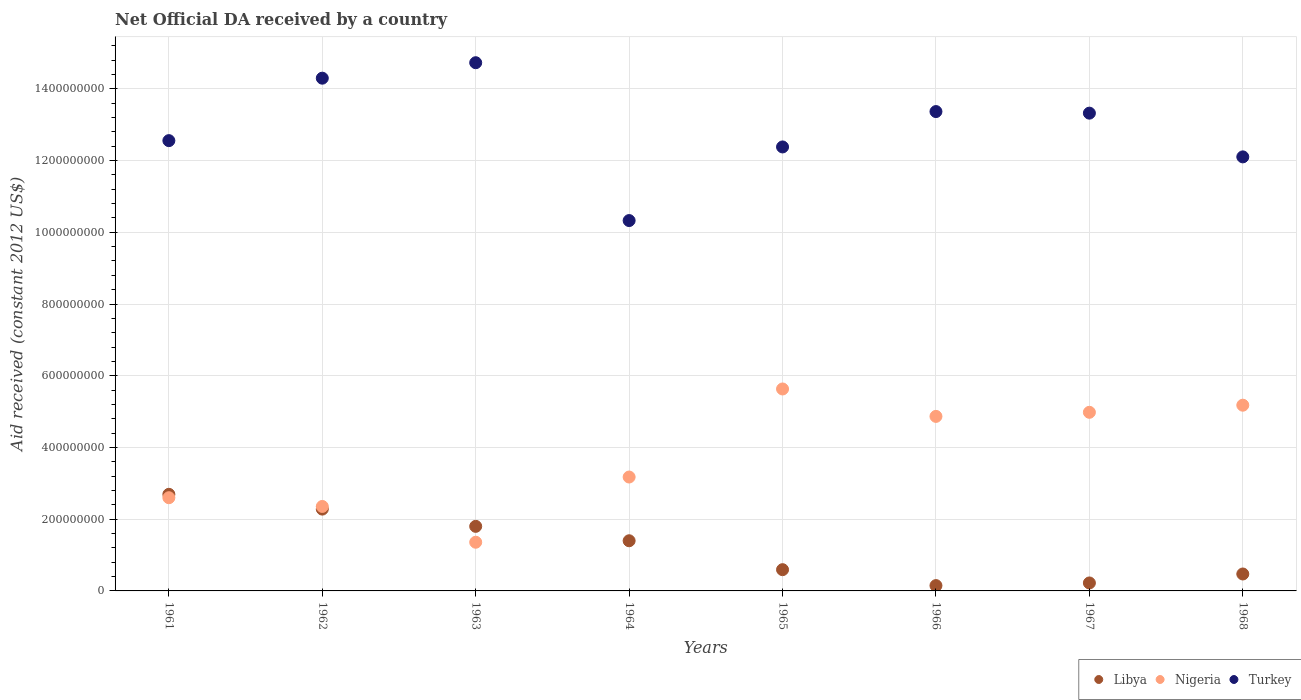What is the net official development assistance aid received in Nigeria in 1962?
Your answer should be compact. 2.36e+08. Across all years, what is the maximum net official development assistance aid received in Nigeria?
Your response must be concise. 5.63e+08. Across all years, what is the minimum net official development assistance aid received in Nigeria?
Your response must be concise. 1.36e+08. In which year was the net official development assistance aid received in Nigeria maximum?
Ensure brevity in your answer.  1965. What is the total net official development assistance aid received in Turkey in the graph?
Your response must be concise. 1.03e+1. What is the difference between the net official development assistance aid received in Libya in 1965 and that in 1968?
Your answer should be very brief. 1.20e+07. What is the difference between the net official development assistance aid received in Libya in 1968 and the net official development assistance aid received in Turkey in 1963?
Ensure brevity in your answer.  -1.43e+09. What is the average net official development assistance aid received in Libya per year?
Your answer should be very brief. 1.20e+08. In the year 1965, what is the difference between the net official development assistance aid received in Turkey and net official development assistance aid received in Nigeria?
Your answer should be very brief. 6.75e+08. In how many years, is the net official development assistance aid received in Nigeria greater than 200000000 US$?
Give a very brief answer. 7. What is the ratio of the net official development assistance aid received in Libya in 1962 to that in 1963?
Make the answer very short. 1.27. What is the difference between the highest and the second highest net official development assistance aid received in Libya?
Offer a terse response. 4.12e+07. What is the difference between the highest and the lowest net official development assistance aid received in Turkey?
Provide a short and direct response. 4.40e+08. In how many years, is the net official development assistance aid received in Libya greater than the average net official development assistance aid received in Libya taken over all years?
Offer a very short reply. 4. Does the net official development assistance aid received in Nigeria monotonically increase over the years?
Provide a succinct answer. No. Is the net official development assistance aid received in Turkey strictly greater than the net official development assistance aid received in Nigeria over the years?
Make the answer very short. Yes. How many dotlines are there?
Provide a short and direct response. 3. Are the values on the major ticks of Y-axis written in scientific E-notation?
Provide a succinct answer. No. Does the graph contain any zero values?
Make the answer very short. No. Where does the legend appear in the graph?
Your answer should be very brief. Bottom right. How are the legend labels stacked?
Give a very brief answer. Horizontal. What is the title of the graph?
Keep it short and to the point. Net Official DA received by a country. What is the label or title of the X-axis?
Your answer should be very brief. Years. What is the label or title of the Y-axis?
Your answer should be very brief. Aid received (constant 2012 US$). What is the Aid received (constant 2012 US$) of Libya in 1961?
Your response must be concise. 2.69e+08. What is the Aid received (constant 2012 US$) of Nigeria in 1961?
Provide a succinct answer. 2.60e+08. What is the Aid received (constant 2012 US$) of Turkey in 1961?
Give a very brief answer. 1.26e+09. What is the Aid received (constant 2012 US$) in Libya in 1962?
Provide a succinct answer. 2.28e+08. What is the Aid received (constant 2012 US$) in Nigeria in 1962?
Provide a short and direct response. 2.36e+08. What is the Aid received (constant 2012 US$) of Turkey in 1962?
Make the answer very short. 1.43e+09. What is the Aid received (constant 2012 US$) in Libya in 1963?
Make the answer very short. 1.80e+08. What is the Aid received (constant 2012 US$) in Nigeria in 1963?
Offer a very short reply. 1.36e+08. What is the Aid received (constant 2012 US$) of Turkey in 1963?
Your response must be concise. 1.47e+09. What is the Aid received (constant 2012 US$) of Libya in 1964?
Keep it short and to the point. 1.40e+08. What is the Aid received (constant 2012 US$) of Nigeria in 1964?
Offer a terse response. 3.18e+08. What is the Aid received (constant 2012 US$) of Turkey in 1964?
Provide a succinct answer. 1.03e+09. What is the Aid received (constant 2012 US$) of Libya in 1965?
Provide a short and direct response. 5.92e+07. What is the Aid received (constant 2012 US$) in Nigeria in 1965?
Your answer should be very brief. 5.63e+08. What is the Aid received (constant 2012 US$) in Turkey in 1965?
Your answer should be compact. 1.24e+09. What is the Aid received (constant 2012 US$) of Libya in 1966?
Provide a succinct answer. 1.49e+07. What is the Aid received (constant 2012 US$) of Nigeria in 1966?
Your answer should be compact. 4.87e+08. What is the Aid received (constant 2012 US$) of Turkey in 1966?
Offer a very short reply. 1.34e+09. What is the Aid received (constant 2012 US$) in Libya in 1967?
Give a very brief answer. 2.22e+07. What is the Aid received (constant 2012 US$) in Nigeria in 1967?
Your answer should be compact. 4.98e+08. What is the Aid received (constant 2012 US$) of Turkey in 1967?
Provide a succinct answer. 1.33e+09. What is the Aid received (constant 2012 US$) of Libya in 1968?
Provide a short and direct response. 4.72e+07. What is the Aid received (constant 2012 US$) of Nigeria in 1968?
Your response must be concise. 5.18e+08. What is the Aid received (constant 2012 US$) in Turkey in 1968?
Ensure brevity in your answer.  1.21e+09. Across all years, what is the maximum Aid received (constant 2012 US$) of Libya?
Offer a very short reply. 2.69e+08. Across all years, what is the maximum Aid received (constant 2012 US$) of Nigeria?
Offer a very short reply. 5.63e+08. Across all years, what is the maximum Aid received (constant 2012 US$) of Turkey?
Your response must be concise. 1.47e+09. Across all years, what is the minimum Aid received (constant 2012 US$) in Libya?
Make the answer very short. 1.49e+07. Across all years, what is the minimum Aid received (constant 2012 US$) in Nigeria?
Your answer should be very brief. 1.36e+08. Across all years, what is the minimum Aid received (constant 2012 US$) of Turkey?
Your answer should be compact. 1.03e+09. What is the total Aid received (constant 2012 US$) of Libya in the graph?
Give a very brief answer. 9.61e+08. What is the total Aid received (constant 2012 US$) in Nigeria in the graph?
Provide a short and direct response. 3.01e+09. What is the total Aid received (constant 2012 US$) of Turkey in the graph?
Your answer should be very brief. 1.03e+1. What is the difference between the Aid received (constant 2012 US$) of Libya in 1961 and that in 1962?
Your answer should be compact. 4.12e+07. What is the difference between the Aid received (constant 2012 US$) of Nigeria in 1961 and that in 1962?
Make the answer very short. 2.44e+07. What is the difference between the Aid received (constant 2012 US$) of Turkey in 1961 and that in 1962?
Provide a short and direct response. -1.74e+08. What is the difference between the Aid received (constant 2012 US$) in Libya in 1961 and that in 1963?
Give a very brief answer. 8.93e+07. What is the difference between the Aid received (constant 2012 US$) of Nigeria in 1961 and that in 1963?
Keep it short and to the point. 1.24e+08. What is the difference between the Aid received (constant 2012 US$) of Turkey in 1961 and that in 1963?
Your answer should be compact. -2.17e+08. What is the difference between the Aid received (constant 2012 US$) in Libya in 1961 and that in 1964?
Your answer should be very brief. 1.29e+08. What is the difference between the Aid received (constant 2012 US$) in Nigeria in 1961 and that in 1964?
Provide a succinct answer. -5.77e+07. What is the difference between the Aid received (constant 2012 US$) of Turkey in 1961 and that in 1964?
Keep it short and to the point. 2.23e+08. What is the difference between the Aid received (constant 2012 US$) in Libya in 1961 and that in 1965?
Your response must be concise. 2.10e+08. What is the difference between the Aid received (constant 2012 US$) of Nigeria in 1961 and that in 1965?
Keep it short and to the point. -3.03e+08. What is the difference between the Aid received (constant 2012 US$) of Turkey in 1961 and that in 1965?
Your response must be concise. 1.76e+07. What is the difference between the Aid received (constant 2012 US$) of Libya in 1961 and that in 1966?
Ensure brevity in your answer.  2.54e+08. What is the difference between the Aid received (constant 2012 US$) in Nigeria in 1961 and that in 1966?
Give a very brief answer. -2.27e+08. What is the difference between the Aid received (constant 2012 US$) in Turkey in 1961 and that in 1966?
Offer a terse response. -8.10e+07. What is the difference between the Aid received (constant 2012 US$) in Libya in 1961 and that in 1967?
Offer a very short reply. 2.47e+08. What is the difference between the Aid received (constant 2012 US$) of Nigeria in 1961 and that in 1967?
Offer a very short reply. -2.38e+08. What is the difference between the Aid received (constant 2012 US$) in Turkey in 1961 and that in 1967?
Offer a very short reply. -7.66e+07. What is the difference between the Aid received (constant 2012 US$) in Libya in 1961 and that in 1968?
Keep it short and to the point. 2.22e+08. What is the difference between the Aid received (constant 2012 US$) of Nigeria in 1961 and that in 1968?
Give a very brief answer. -2.58e+08. What is the difference between the Aid received (constant 2012 US$) in Turkey in 1961 and that in 1968?
Ensure brevity in your answer.  4.53e+07. What is the difference between the Aid received (constant 2012 US$) in Libya in 1962 and that in 1963?
Your answer should be compact. 4.81e+07. What is the difference between the Aid received (constant 2012 US$) of Nigeria in 1962 and that in 1963?
Give a very brief answer. 9.98e+07. What is the difference between the Aid received (constant 2012 US$) in Turkey in 1962 and that in 1963?
Your answer should be compact. -4.31e+07. What is the difference between the Aid received (constant 2012 US$) in Libya in 1962 and that in 1964?
Keep it short and to the point. 8.83e+07. What is the difference between the Aid received (constant 2012 US$) in Nigeria in 1962 and that in 1964?
Give a very brief answer. -8.20e+07. What is the difference between the Aid received (constant 2012 US$) of Turkey in 1962 and that in 1964?
Your answer should be very brief. 3.97e+08. What is the difference between the Aid received (constant 2012 US$) in Libya in 1962 and that in 1965?
Give a very brief answer. 1.69e+08. What is the difference between the Aid received (constant 2012 US$) of Nigeria in 1962 and that in 1965?
Offer a very short reply. -3.28e+08. What is the difference between the Aid received (constant 2012 US$) in Turkey in 1962 and that in 1965?
Offer a very short reply. 1.92e+08. What is the difference between the Aid received (constant 2012 US$) in Libya in 1962 and that in 1966?
Your answer should be compact. 2.13e+08. What is the difference between the Aid received (constant 2012 US$) in Nigeria in 1962 and that in 1966?
Your response must be concise. -2.51e+08. What is the difference between the Aid received (constant 2012 US$) in Turkey in 1962 and that in 1966?
Keep it short and to the point. 9.31e+07. What is the difference between the Aid received (constant 2012 US$) in Libya in 1962 and that in 1967?
Offer a very short reply. 2.06e+08. What is the difference between the Aid received (constant 2012 US$) in Nigeria in 1962 and that in 1967?
Offer a very short reply. -2.63e+08. What is the difference between the Aid received (constant 2012 US$) in Turkey in 1962 and that in 1967?
Your answer should be very brief. 9.75e+07. What is the difference between the Aid received (constant 2012 US$) of Libya in 1962 and that in 1968?
Your answer should be very brief. 1.81e+08. What is the difference between the Aid received (constant 2012 US$) of Nigeria in 1962 and that in 1968?
Provide a short and direct response. -2.82e+08. What is the difference between the Aid received (constant 2012 US$) of Turkey in 1962 and that in 1968?
Ensure brevity in your answer.  2.19e+08. What is the difference between the Aid received (constant 2012 US$) of Libya in 1963 and that in 1964?
Offer a very short reply. 4.02e+07. What is the difference between the Aid received (constant 2012 US$) in Nigeria in 1963 and that in 1964?
Provide a short and direct response. -1.82e+08. What is the difference between the Aid received (constant 2012 US$) of Turkey in 1963 and that in 1964?
Ensure brevity in your answer.  4.40e+08. What is the difference between the Aid received (constant 2012 US$) in Libya in 1963 and that in 1965?
Ensure brevity in your answer.  1.21e+08. What is the difference between the Aid received (constant 2012 US$) in Nigeria in 1963 and that in 1965?
Provide a succinct answer. -4.27e+08. What is the difference between the Aid received (constant 2012 US$) of Turkey in 1963 and that in 1965?
Your response must be concise. 2.35e+08. What is the difference between the Aid received (constant 2012 US$) in Libya in 1963 and that in 1966?
Provide a short and direct response. 1.65e+08. What is the difference between the Aid received (constant 2012 US$) in Nigeria in 1963 and that in 1966?
Keep it short and to the point. -3.51e+08. What is the difference between the Aid received (constant 2012 US$) of Turkey in 1963 and that in 1966?
Offer a very short reply. 1.36e+08. What is the difference between the Aid received (constant 2012 US$) in Libya in 1963 and that in 1967?
Keep it short and to the point. 1.58e+08. What is the difference between the Aid received (constant 2012 US$) in Nigeria in 1963 and that in 1967?
Make the answer very short. -3.62e+08. What is the difference between the Aid received (constant 2012 US$) of Turkey in 1963 and that in 1967?
Offer a very short reply. 1.41e+08. What is the difference between the Aid received (constant 2012 US$) of Libya in 1963 and that in 1968?
Offer a terse response. 1.33e+08. What is the difference between the Aid received (constant 2012 US$) of Nigeria in 1963 and that in 1968?
Offer a very short reply. -3.82e+08. What is the difference between the Aid received (constant 2012 US$) of Turkey in 1963 and that in 1968?
Give a very brief answer. 2.63e+08. What is the difference between the Aid received (constant 2012 US$) of Libya in 1964 and that in 1965?
Offer a very short reply. 8.06e+07. What is the difference between the Aid received (constant 2012 US$) of Nigeria in 1964 and that in 1965?
Provide a succinct answer. -2.46e+08. What is the difference between the Aid received (constant 2012 US$) in Turkey in 1964 and that in 1965?
Your answer should be compact. -2.05e+08. What is the difference between the Aid received (constant 2012 US$) of Libya in 1964 and that in 1966?
Your response must be concise. 1.25e+08. What is the difference between the Aid received (constant 2012 US$) of Nigeria in 1964 and that in 1966?
Provide a succinct answer. -1.69e+08. What is the difference between the Aid received (constant 2012 US$) of Turkey in 1964 and that in 1966?
Your answer should be compact. -3.04e+08. What is the difference between the Aid received (constant 2012 US$) in Libya in 1964 and that in 1967?
Your answer should be very brief. 1.18e+08. What is the difference between the Aid received (constant 2012 US$) of Nigeria in 1964 and that in 1967?
Keep it short and to the point. -1.80e+08. What is the difference between the Aid received (constant 2012 US$) of Turkey in 1964 and that in 1967?
Your answer should be very brief. -3.00e+08. What is the difference between the Aid received (constant 2012 US$) of Libya in 1964 and that in 1968?
Offer a terse response. 9.26e+07. What is the difference between the Aid received (constant 2012 US$) in Nigeria in 1964 and that in 1968?
Offer a terse response. -2.00e+08. What is the difference between the Aid received (constant 2012 US$) of Turkey in 1964 and that in 1968?
Your answer should be compact. -1.78e+08. What is the difference between the Aid received (constant 2012 US$) of Libya in 1965 and that in 1966?
Your response must be concise. 4.44e+07. What is the difference between the Aid received (constant 2012 US$) in Nigeria in 1965 and that in 1966?
Offer a very short reply. 7.64e+07. What is the difference between the Aid received (constant 2012 US$) in Turkey in 1965 and that in 1966?
Offer a very short reply. -9.86e+07. What is the difference between the Aid received (constant 2012 US$) in Libya in 1965 and that in 1967?
Your response must be concise. 3.70e+07. What is the difference between the Aid received (constant 2012 US$) of Nigeria in 1965 and that in 1967?
Give a very brief answer. 6.51e+07. What is the difference between the Aid received (constant 2012 US$) in Turkey in 1965 and that in 1967?
Provide a succinct answer. -9.42e+07. What is the difference between the Aid received (constant 2012 US$) in Libya in 1965 and that in 1968?
Provide a short and direct response. 1.20e+07. What is the difference between the Aid received (constant 2012 US$) of Nigeria in 1965 and that in 1968?
Your answer should be very brief. 4.52e+07. What is the difference between the Aid received (constant 2012 US$) of Turkey in 1965 and that in 1968?
Keep it short and to the point. 2.77e+07. What is the difference between the Aid received (constant 2012 US$) in Libya in 1966 and that in 1967?
Keep it short and to the point. -7.36e+06. What is the difference between the Aid received (constant 2012 US$) of Nigeria in 1966 and that in 1967?
Your answer should be very brief. -1.14e+07. What is the difference between the Aid received (constant 2012 US$) in Turkey in 1966 and that in 1967?
Give a very brief answer. 4.41e+06. What is the difference between the Aid received (constant 2012 US$) of Libya in 1966 and that in 1968?
Ensure brevity in your answer.  -3.24e+07. What is the difference between the Aid received (constant 2012 US$) in Nigeria in 1966 and that in 1968?
Provide a succinct answer. -3.12e+07. What is the difference between the Aid received (constant 2012 US$) of Turkey in 1966 and that in 1968?
Your answer should be very brief. 1.26e+08. What is the difference between the Aid received (constant 2012 US$) in Libya in 1967 and that in 1968?
Your response must be concise. -2.50e+07. What is the difference between the Aid received (constant 2012 US$) in Nigeria in 1967 and that in 1968?
Give a very brief answer. -1.98e+07. What is the difference between the Aid received (constant 2012 US$) of Turkey in 1967 and that in 1968?
Offer a very short reply. 1.22e+08. What is the difference between the Aid received (constant 2012 US$) of Libya in 1961 and the Aid received (constant 2012 US$) of Nigeria in 1962?
Provide a succinct answer. 3.38e+07. What is the difference between the Aid received (constant 2012 US$) in Libya in 1961 and the Aid received (constant 2012 US$) in Turkey in 1962?
Ensure brevity in your answer.  -1.16e+09. What is the difference between the Aid received (constant 2012 US$) in Nigeria in 1961 and the Aid received (constant 2012 US$) in Turkey in 1962?
Offer a very short reply. -1.17e+09. What is the difference between the Aid received (constant 2012 US$) of Libya in 1961 and the Aid received (constant 2012 US$) of Nigeria in 1963?
Provide a short and direct response. 1.34e+08. What is the difference between the Aid received (constant 2012 US$) of Libya in 1961 and the Aid received (constant 2012 US$) of Turkey in 1963?
Offer a terse response. -1.20e+09. What is the difference between the Aid received (constant 2012 US$) in Nigeria in 1961 and the Aid received (constant 2012 US$) in Turkey in 1963?
Your answer should be very brief. -1.21e+09. What is the difference between the Aid received (constant 2012 US$) of Libya in 1961 and the Aid received (constant 2012 US$) of Nigeria in 1964?
Provide a short and direct response. -4.82e+07. What is the difference between the Aid received (constant 2012 US$) in Libya in 1961 and the Aid received (constant 2012 US$) in Turkey in 1964?
Your answer should be very brief. -7.63e+08. What is the difference between the Aid received (constant 2012 US$) of Nigeria in 1961 and the Aid received (constant 2012 US$) of Turkey in 1964?
Offer a terse response. -7.73e+08. What is the difference between the Aid received (constant 2012 US$) of Libya in 1961 and the Aid received (constant 2012 US$) of Nigeria in 1965?
Your answer should be compact. -2.94e+08. What is the difference between the Aid received (constant 2012 US$) in Libya in 1961 and the Aid received (constant 2012 US$) in Turkey in 1965?
Keep it short and to the point. -9.69e+08. What is the difference between the Aid received (constant 2012 US$) in Nigeria in 1961 and the Aid received (constant 2012 US$) in Turkey in 1965?
Provide a short and direct response. -9.78e+08. What is the difference between the Aid received (constant 2012 US$) of Libya in 1961 and the Aid received (constant 2012 US$) of Nigeria in 1966?
Ensure brevity in your answer.  -2.17e+08. What is the difference between the Aid received (constant 2012 US$) of Libya in 1961 and the Aid received (constant 2012 US$) of Turkey in 1966?
Provide a short and direct response. -1.07e+09. What is the difference between the Aid received (constant 2012 US$) of Nigeria in 1961 and the Aid received (constant 2012 US$) of Turkey in 1966?
Offer a terse response. -1.08e+09. What is the difference between the Aid received (constant 2012 US$) in Libya in 1961 and the Aid received (constant 2012 US$) in Nigeria in 1967?
Keep it short and to the point. -2.29e+08. What is the difference between the Aid received (constant 2012 US$) in Libya in 1961 and the Aid received (constant 2012 US$) in Turkey in 1967?
Ensure brevity in your answer.  -1.06e+09. What is the difference between the Aid received (constant 2012 US$) of Nigeria in 1961 and the Aid received (constant 2012 US$) of Turkey in 1967?
Provide a short and direct response. -1.07e+09. What is the difference between the Aid received (constant 2012 US$) of Libya in 1961 and the Aid received (constant 2012 US$) of Nigeria in 1968?
Ensure brevity in your answer.  -2.49e+08. What is the difference between the Aid received (constant 2012 US$) of Libya in 1961 and the Aid received (constant 2012 US$) of Turkey in 1968?
Ensure brevity in your answer.  -9.41e+08. What is the difference between the Aid received (constant 2012 US$) in Nigeria in 1961 and the Aid received (constant 2012 US$) in Turkey in 1968?
Keep it short and to the point. -9.50e+08. What is the difference between the Aid received (constant 2012 US$) of Libya in 1962 and the Aid received (constant 2012 US$) of Nigeria in 1963?
Ensure brevity in your answer.  9.24e+07. What is the difference between the Aid received (constant 2012 US$) of Libya in 1962 and the Aid received (constant 2012 US$) of Turkey in 1963?
Provide a short and direct response. -1.24e+09. What is the difference between the Aid received (constant 2012 US$) in Nigeria in 1962 and the Aid received (constant 2012 US$) in Turkey in 1963?
Your answer should be compact. -1.24e+09. What is the difference between the Aid received (constant 2012 US$) of Libya in 1962 and the Aid received (constant 2012 US$) of Nigeria in 1964?
Provide a short and direct response. -8.94e+07. What is the difference between the Aid received (constant 2012 US$) of Libya in 1962 and the Aid received (constant 2012 US$) of Turkey in 1964?
Provide a succinct answer. -8.05e+08. What is the difference between the Aid received (constant 2012 US$) of Nigeria in 1962 and the Aid received (constant 2012 US$) of Turkey in 1964?
Provide a succinct answer. -7.97e+08. What is the difference between the Aid received (constant 2012 US$) in Libya in 1962 and the Aid received (constant 2012 US$) in Nigeria in 1965?
Ensure brevity in your answer.  -3.35e+08. What is the difference between the Aid received (constant 2012 US$) of Libya in 1962 and the Aid received (constant 2012 US$) of Turkey in 1965?
Your answer should be very brief. -1.01e+09. What is the difference between the Aid received (constant 2012 US$) of Nigeria in 1962 and the Aid received (constant 2012 US$) of Turkey in 1965?
Your response must be concise. -1.00e+09. What is the difference between the Aid received (constant 2012 US$) of Libya in 1962 and the Aid received (constant 2012 US$) of Nigeria in 1966?
Your response must be concise. -2.59e+08. What is the difference between the Aid received (constant 2012 US$) of Libya in 1962 and the Aid received (constant 2012 US$) of Turkey in 1966?
Offer a very short reply. -1.11e+09. What is the difference between the Aid received (constant 2012 US$) of Nigeria in 1962 and the Aid received (constant 2012 US$) of Turkey in 1966?
Keep it short and to the point. -1.10e+09. What is the difference between the Aid received (constant 2012 US$) in Libya in 1962 and the Aid received (constant 2012 US$) in Nigeria in 1967?
Offer a very short reply. -2.70e+08. What is the difference between the Aid received (constant 2012 US$) in Libya in 1962 and the Aid received (constant 2012 US$) in Turkey in 1967?
Provide a succinct answer. -1.10e+09. What is the difference between the Aid received (constant 2012 US$) in Nigeria in 1962 and the Aid received (constant 2012 US$) in Turkey in 1967?
Provide a short and direct response. -1.10e+09. What is the difference between the Aid received (constant 2012 US$) of Libya in 1962 and the Aid received (constant 2012 US$) of Nigeria in 1968?
Keep it short and to the point. -2.90e+08. What is the difference between the Aid received (constant 2012 US$) of Libya in 1962 and the Aid received (constant 2012 US$) of Turkey in 1968?
Your answer should be compact. -9.82e+08. What is the difference between the Aid received (constant 2012 US$) of Nigeria in 1962 and the Aid received (constant 2012 US$) of Turkey in 1968?
Provide a short and direct response. -9.75e+08. What is the difference between the Aid received (constant 2012 US$) in Libya in 1963 and the Aid received (constant 2012 US$) in Nigeria in 1964?
Your response must be concise. -1.38e+08. What is the difference between the Aid received (constant 2012 US$) of Libya in 1963 and the Aid received (constant 2012 US$) of Turkey in 1964?
Provide a short and direct response. -8.53e+08. What is the difference between the Aid received (constant 2012 US$) of Nigeria in 1963 and the Aid received (constant 2012 US$) of Turkey in 1964?
Provide a short and direct response. -8.97e+08. What is the difference between the Aid received (constant 2012 US$) of Libya in 1963 and the Aid received (constant 2012 US$) of Nigeria in 1965?
Your answer should be very brief. -3.83e+08. What is the difference between the Aid received (constant 2012 US$) in Libya in 1963 and the Aid received (constant 2012 US$) in Turkey in 1965?
Keep it short and to the point. -1.06e+09. What is the difference between the Aid received (constant 2012 US$) in Nigeria in 1963 and the Aid received (constant 2012 US$) in Turkey in 1965?
Keep it short and to the point. -1.10e+09. What is the difference between the Aid received (constant 2012 US$) of Libya in 1963 and the Aid received (constant 2012 US$) of Nigeria in 1966?
Your answer should be very brief. -3.07e+08. What is the difference between the Aid received (constant 2012 US$) in Libya in 1963 and the Aid received (constant 2012 US$) in Turkey in 1966?
Your response must be concise. -1.16e+09. What is the difference between the Aid received (constant 2012 US$) of Nigeria in 1963 and the Aid received (constant 2012 US$) of Turkey in 1966?
Your answer should be compact. -1.20e+09. What is the difference between the Aid received (constant 2012 US$) of Libya in 1963 and the Aid received (constant 2012 US$) of Nigeria in 1967?
Your answer should be very brief. -3.18e+08. What is the difference between the Aid received (constant 2012 US$) in Libya in 1963 and the Aid received (constant 2012 US$) in Turkey in 1967?
Provide a short and direct response. -1.15e+09. What is the difference between the Aid received (constant 2012 US$) of Nigeria in 1963 and the Aid received (constant 2012 US$) of Turkey in 1967?
Offer a terse response. -1.20e+09. What is the difference between the Aid received (constant 2012 US$) of Libya in 1963 and the Aid received (constant 2012 US$) of Nigeria in 1968?
Make the answer very short. -3.38e+08. What is the difference between the Aid received (constant 2012 US$) of Libya in 1963 and the Aid received (constant 2012 US$) of Turkey in 1968?
Provide a short and direct response. -1.03e+09. What is the difference between the Aid received (constant 2012 US$) in Nigeria in 1963 and the Aid received (constant 2012 US$) in Turkey in 1968?
Your answer should be compact. -1.07e+09. What is the difference between the Aid received (constant 2012 US$) in Libya in 1964 and the Aid received (constant 2012 US$) in Nigeria in 1965?
Offer a terse response. -4.23e+08. What is the difference between the Aid received (constant 2012 US$) of Libya in 1964 and the Aid received (constant 2012 US$) of Turkey in 1965?
Your answer should be compact. -1.10e+09. What is the difference between the Aid received (constant 2012 US$) in Nigeria in 1964 and the Aid received (constant 2012 US$) in Turkey in 1965?
Provide a short and direct response. -9.20e+08. What is the difference between the Aid received (constant 2012 US$) of Libya in 1964 and the Aid received (constant 2012 US$) of Nigeria in 1966?
Offer a terse response. -3.47e+08. What is the difference between the Aid received (constant 2012 US$) of Libya in 1964 and the Aid received (constant 2012 US$) of Turkey in 1966?
Provide a succinct answer. -1.20e+09. What is the difference between the Aid received (constant 2012 US$) in Nigeria in 1964 and the Aid received (constant 2012 US$) in Turkey in 1966?
Offer a very short reply. -1.02e+09. What is the difference between the Aid received (constant 2012 US$) in Libya in 1964 and the Aid received (constant 2012 US$) in Nigeria in 1967?
Your answer should be very brief. -3.58e+08. What is the difference between the Aid received (constant 2012 US$) in Libya in 1964 and the Aid received (constant 2012 US$) in Turkey in 1967?
Your response must be concise. -1.19e+09. What is the difference between the Aid received (constant 2012 US$) of Nigeria in 1964 and the Aid received (constant 2012 US$) of Turkey in 1967?
Keep it short and to the point. -1.01e+09. What is the difference between the Aid received (constant 2012 US$) in Libya in 1964 and the Aid received (constant 2012 US$) in Nigeria in 1968?
Your answer should be compact. -3.78e+08. What is the difference between the Aid received (constant 2012 US$) of Libya in 1964 and the Aid received (constant 2012 US$) of Turkey in 1968?
Offer a very short reply. -1.07e+09. What is the difference between the Aid received (constant 2012 US$) of Nigeria in 1964 and the Aid received (constant 2012 US$) of Turkey in 1968?
Your answer should be compact. -8.93e+08. What is the difference between the Aid received (constant 2012 US$) in Libya in 1965 and the Aid received (constant 2012 US$) in Nigeria in 1966?
Your answer should be compact. -4.27e+08. What is the difference between the Aid received (constant 2012 US$) of Libya in 1965 and the Aid received (constant 2012 US$) of Turkey in 1966?
Keep it short and to the point. -1.28e+09. What is the difference between the Aid received (constant 2012 US$) in Nigeria in 1965 and the Aid received (constant 2012 US$) in Turkey in 1966?
Make the answer very short. -7.74e+08. What is the difference between the Aid received (constant 2012 US$) in Libya in 1965 and the Aid received (constant 2012 US$) in Nigeria in 1967?
Provide a succinct answer. -4.39e+08. What is the difference between the Aid received (constant 2012 US$) in Libya in 1965 and the Aid received (constant 2012 US$) in Turkey in 1967?
Ensure brevity in your answer.  -1.27e+09. What is the difference between the Aid received (constant 2012 US$) in Nigeria in 1965 and the Aid received (constant 2012 US$) in Turkey in 1967?
Offer a very short reply. -7.69e+08. What is the difference between the Aid received (constant 2012 US$) of Libya in 1965 and the Aid received (constant 2012 US$) of Nigeria in 1968?
Your answer should be very brief. -4.59e+08. What is the difference between the Aid received (constant 2012 US$) of Libya in 1965 and the Aid received (constant 2012 US$) of Turkey in 1968?
Provide a short and direct response. -1.15e+09. What is the difference between the Aid received (constant 2012 US$) in Nigeria in 1965 and the Aid received (constant 2012 US$) in Turkey in 1968?
Give a very brief answer. -6.47e+08. What is the difference between the Aid received (constant 2012 US$) of Libya in 1966 and the Aid received (constant 2012 US$) of Nigeria in 1967?
Offer a very short reply. -4.83e+08. What is the difference between the Aid received (constant 2012 US$) in Libya in 1966 and the Aid received (constant 2012 US$) in Turkey in 1967?
Keep it short and to the point. -1.32e+09. What is the difference between the Aid received (constant 2012 US$) of Nigeria in 1966 and the Aid received (constant 2012 US$) of Turkey in 1967?
Ensure brevity in your answer.  -8.46e+08. What is the difference between the Aid received (constant 2012 US$) of Libya in 1966 and the Aid received (constant 2012 US$) of Nigeria in 1968?
Offer a terse response. -5.03e+08. What is the difference between the Aid received (constant 2012 US$) in Libya in 1966 and the Aid received (constant 2012 US$) in Turkey in 1968?
Give a very brief answer. -1.20e+09. What is the difference between the Aid received (constant 2012 US$) of Nigeria in 1966 and the Aid received (constant 2012 US$) of Turkey in 1968?
Keep it short and to the point. -7.24e+08. What is the difference between the Aid received (constant 2012 US$) of Libya in 1967 and the Aid received (constant 2012 US$) of Nigeria in 1968?
Offer a terse response. -4.96e+08. What is the difference between the Aid received (constant 2012 US$) in Libya in 1967 and the Aid received (constant 2012 US$) in Turkey in 1968?
Give a very brief answer. -1.19e+09. What is the difference between the Aid received (constant 2012 US$) in Nigeria in 1967 and the Aid received (constant 2012 US$) in Turkey in 1968?
Make the answer very short. -7.12e+08. What is the average Aid received (constant 2012 US$) in Libya per year?
Provide a short and direct response. 1.20e+08. What is the average Aid received (constant 2012 US$) of Nigeria per year?
Provide a short and direct response. 3.77e+08. What is the average Aid received (constant 2012 US$) of Turkey per year?
Your answer should be very brief. 1.29e+09. In the year 1961, what is the difference between the Aid received (constant 2012 US$) of Libya and Aid received (constant 2012 US$) of Nigeria?
Offer a terse response. 9.44e+06. In the year 1961, what is the difference between the Aid received (constant 2012 US$) of Libya and Aid received (constant 2012 US$) of Turkey?
Your answer should be very brief. -9.86e+08. In the year 1961, what is the difference between the Aid received (constant 2012 US$) of Nigeria and Aid received (constant 2012 US$) of Turkey?
Your answer should be very brief. -9.96e+08. In the year 1962, what is the difference between the Aid received (constant 2012 US$) in Libya and Aid received (constant 2012 US$) in Nigeria?
Your answer should be very brief. -7.38e+06. In the year 1962, what is the difference between the Aid received (constant 2012 US$) in Libya and Aid received (constant 2012 US$) in Turkey?
Give a very brief answer. -1.20e+09. In the year 1962, what is the difference between the Aid received (constant 2012 US$) in Nigeria and Aid received (constant 2012 US$) in Turkey?
Provide a short and direct response. -1.19e+09. In the year 1963, what is the difference between the Aid received (constant 2012 US$) in Libya and Aid received (constant 2012 US$) in Nigeria?
Your answer should be very brief. 4.43e+07. In the year 1963, what is the difference between the Aid received (constant 2012 US$) in Libya and Aid received (constant 2012 US$) in Turkey?
Ensure brevity in your answer.  -1.29e+09. In the year 1963, what is the difference between the Aid received (constant 2012 US$) in Nigeria and Aid received (constant 2012 US$) in Turkey?
Provide a succinct answer. -1.34e+09. In the year 1964, what is the difference between the Aid received (constant 2012 US$) of Libya and Aid received (constant 2012 US$) of Nigeria?
Offer a very short reply. -1.78e+08. In the year 1964, what is the difference between the Aid received (constant 2012 US$) in Libya and Aid received (constant 2012 US$) in Turkey?
Your response must be concise. -8.93e+08. In the year 1964, what is the difference between the Aid received (constant 2012 US$) in Nigeria and Aid received (constant 2012 US$) in Turkey?
Your response must be concise. -7.15e+08. In the year 1965, what is the difference between the Aid received (constant 2012 US$) of Libya and Aid received (constant 2012 US$) of Nigeria?
Ensure brevity in your answer.  -5.04e+08. In the year 1965, what is the difference between the Aid received (constant 2012 US$) of Libya and Aid received (constant 2012 US$) of Turkey?
Make the answer very short. -1.18e+09. In the year 1965, what is the difference between the Aid received (constant 2012 US$) of Nigeria and Aid received (constant 2012 US$) of Turkey?
Provide a short and direct response. -6.75e+08. In the year 1966, what is the difference between the Aid received (constant 2012 US$) in Libya and Aid received (constant 2012 US$) in Nigeria?
Offer a very short reply. -4.72e+08. In the year 1966, what is the difference between the Aid received (constant 2012 US$) in Libya and Aid received (constant 2012 US$) in Turkey?
Make the answer very short. -1.32e+09. In the year 1966, what is the difference between the Aid received (constant 2012 US$) in Nigeria and Aid received (constant 2012 US$) in Turkey?
Your answer should be very brief. -8.50e+08. In the year 1967, what is the difference between the Aid received (constant 2012 US$) of Libya and Aid received (constant 2012 US$) of Nigeria?
Ensure brevity in your answer.  -4.76e+08. In the year 1967, what is the difference between the Aid received (constant 2012 US$) of Libya and Aid received (constant 2012 US$) of Turkey?
Keep it short and to the point. -1.31e+09. In the year 1967, what is the difference between the Aid received (constant 2012 US$) of Nigeria and Aid received (constant 2012 US$) of Turkey?
Provide a short and direct response. -8.34e+08. In the year 1968, what is the difference between the Aid received (constant 2012 US$) in Libya and Aid received (constant 2012 US$) in Nigeria?
Ensure brevity in your answer.  -4.71e+08. In the year 1968, what is the difference between the Aid received (constant 2012 US$) in Libya and Aid received (constant 2012 US$) in Turkey?
Offer a terse response. -1.16e+09. In the year 1968, what is the difference between the Aid received (constant 2012 US$) of Nigeria and Aid received (constant 2012 US$) of Turkey?
Give a very brief answer. -6.92e+08. What is the ratio of the Aid received (constant 2012 US$) of Libya in 1961 to that in 1962?
Give a very brief answer. 1.18. What is the ratio of the Aid received (constant 2012 US$) of Nigeria in 1961 to that in 1962?
Offer a very short reply. 1.1. What is the ratio of the Aid received (constant 2012 US$) of Turkey in 1961 to that in 1962?
Your answer should be compact. 0.88. What is the ratio of the Aid received (constant 2012 US$) of Libya in 1961 to that in 1963?
Offer a terse response. 1.5. What is the ratio of the Aid received (constant 2012 US$) of Nigeria in 1961 to that in 1963?
Ensure brevity in your answer.  1.91. What is the ratio of the Aid received (constant 2012 US$) in Turkey in 1961 to that in 1963?
Keep it short and to the point. 0.85. What is the ratio of the Aid received (constant 2012 US$) in Libya in 1961 to that in 1964?
Provide a short and direct response. 1.93. What is the ratio of the Aid received (constant 2012 US$) of Nigeria in 1961 to that in 1964?
Offer a terse response. 0.82. What is the ratio of the Aid received (constant 2012 US$) in Turkey in 1961 to that in 1964?
Your answer should be compact. 1.22. What is the ratio of the Aid received (constant 2012 US$) of Libya in 1961 to that in 1965?
Ensure brevity in your answer.  4.55. What is the ratio of the Aid received (constant 2012 US$) of Nigeria in 1961 to that in 1965?
Your answer should be compact. 0.46. What is the ratio of the Aid received (constant 2012 US$) of Turkey in 1961 to that in 1965?
Provide a succinct answer. 1.01. What is the ratio of the Aid received (constant 2012 US$) in Libya in 1961 to that in 1966?
Keep it short and to the point. 18.13. What is the ratio of the Aid received (constant 2012 US$) of Nigeria in 1961 to that in 1966?
Make the answer very short. 0.53. What is the ratio of the Aid received (constant 2012 US$) of Turkey in 1961 to that in 1966?
Ensure brevity in your answer.  0.94. What is the ratio of the Aid received (constant 2012 US$) in Libya in 1961 to that in 1967?
Your response must be concise. 12.12. What is the ratio of the Aid received (constant 2012 US$) in Nigeria in 1961 to that in 1967?
Give a very brief answer. 0.52. What is the ratio of the Aid received (constant 2012 US$) of Turkey in 1961 to that in 1967?
Offer a terse response. 0.94. What is the ratio of the Aid received (constant 2012 US$) of Libya in 1961 to that in 1968?
Provide a succinct answer. 5.7. What is the ratio of the Aid received (constant 2012 US$) of Nigeria in 1961 to that in 1968?
Keep it short and to the point. 0.5. What is the ratio of the Aid received (constant 2012 US$) in Turkey in 1961 to that in 1968?
Give a very brief answer. 1.04. What is the ratio of the Aid received (constant 2012 US$) of Libya in 1962 to that in 1963?
Your answer should be compact. 1.27. What is the ratio of the Aid received (constant 2012 US$) of Nigeria in 1962 to that in 1963?
Offer a very short reply. 1.74. What is the ratio of the Aid received (constant 2012 US$) of Turkey in 1962 to that in 1963?
Keep it short and to the point. 0.97. What is the ratio of the Aid received (constant 2012 US$) of Libya in 1962 to that in 1964?
Make the answer very short. 1.63. What is the ratio of the Aid received (constant 2012 US$) in Nigeria in 1962 to that in 1964?
Give a very brief answer. 0.74. What is the ratio of the Aid received (constant 2012 US$) in Turkey in 1962 to that in 1964?
Your response must be concise. 1.38. What is the ratio of the Aid received (constant 2012 US$) of Libya in 1962 to that in 1965?
Ensure brevity in your answer.  3.85. What is the ratio of the Aid received (constant 2012 US$) of Nigeria in 1962 to that in 1965?
Offer a very short reply. 0.42. What is the ratio of the Aid received (constant 2012 US$) in Turkey in 1962 to that in 1965?
Your answer should be very brief. 1.15. What is the ratio of the Aid received (constant 2012 US$) of Libya in 1962 to that in 1966?
Offer a terse response. 15.35. What is the ratio of the Aid received (constant 2012 US$) in Nigeria in 1962 to that in 1966?
Give a very brief answer. 0.48. What is the ratio of the Aid received (constant 2012 US$) in Turkey in 1962 to that in 1966?
Make the answer very short. 1.07. What is the ratio of the Aid received (constant 2012 US$) in Libya in 1962 to that in 1967?
Your response must be concise. 10.27. What is the ratio of the Aid received (constant 2012 US$) in Nigeria in 1962 to that in 1967?
Offer a terse response. 0.47. What is the ratio of the Aid received (constant 2012 US$) of Turkey in 1962 to that in 1967?
Offer a terse response. 1.07. What is the ratio of the Aid received (constant 2012 US$) in Libya in 1962 to that in 1968?
Ensure brevity in your answer.  4.83. What is the ratio of the Aid received (constant 2012 US$) of Nigeria in 1962 to that in 1968?
Provide a short and direct response. 0.45. What is the ratio of the Aid received (constant 2012 US$) of Turkey in 1962 to that in 1968?
Your answer should be compact. 1.18. What is the ratio of the Aid received (constant 2012 US$) in Libya in 1963 to that in 1964?
Ensure brevity in your answer.  1.29. What is the ratio of the Aid received (constant 2012 US$) in Nigeria in 1963 to that in 1964?
Provide a succinct answer. 0.43. What is the ratio of the Aid received (constant 2012 US$) of Turkey in 1963 to that in 1964?
Offer a very short reply. 1.43. What is the ratio of the Aid received (constant 2012 US$) in Libya in 1963 to that in 1965?
Your answer should be compact. 3.04. What is the ratio of the Aid received (constant 2012 US$) in Nigeria in 1963 to that in 1965?
Offer a very short reply. 0.24. What is the ratio of the Aid received (constant 2012 US$) of Turkey in 1963 to that in 1965?
Ensure brevity in your answer.  1.19. What is the ratio of the Aid received (constant 2012 US$) in Libya in 1963 to that in 1966?
Keep it short and to the point. 12.12. What is the ratio of the Aid received (constant 2012 US$) in Nigeria in 1963 to that in 1966?
Your response must be concise. 0.28. What is the ratio of the Aid received (constant 2012 US$) of Turkey in 1963 to that in 1966?
Give a very brief answer. 1.1. What is the ratio of the Aid received (constant 2012 US$) in Libya in 1963 to that in 1967?
Keep it short and to the point. 8.1. What is the ratio of the Aid received (constant 2012 US$) of Nigeria in 1963 to that in 1967?
Offer a very short reply. 0.27. What is the ratio of the Aid received (constant 2012 US$) in Turkey in 1963 to that in 1967?
Give a very brief answer. 1.11. What is the ratio of the Aid received (constant 2012 US$) of Libya in 1963 to that in 1968?
Provide a succinct answer. 3.81. What is the ratio of the Aid received (constant 2012 US$) in Nigeria in 1963 to that in 1968?
Offer a very short reply. 0.26. What is the ratio of the Aid received (constant 2012 US$) in Turkey in 1963 to that in 1968?
Your answer should be very brief. 1.22. What is the ratio of the Aid received (constant 2012 US$) of Libya in 1964 to that in 1965?
Provide a succinct answer. 2.36. What is the ratio of the Aid received (constant 2012 US$) in Nigeria in 1964 to that in 1965?
Your answer should be very brief. 0.56. What is the ratio of the Aid received (constant 2012 US$) in Turkey in 1964 to that in 1965?
Make the answer very short. 0.83. What is the ratio of the Aid received (constant 2012 US$) of Libya in 1964 to that in 1966?
Keep it short and to the point. 9.41. What is the ratio of the Aid received (constant 2012 US$) in Nigeria in 1964 to that in 1966?
Give a very brief answer. 0.65. What is the ratio of the Aid received (constant 2012 US$) in Turkey in 1964 to that in 1966?
Make the answer very short. 0.77. What is the ratio of the Aid received (constant 2012 US$) of Libya in 1964 to that in 1967?
Offer a terse response. 6.29. What is the ratio of the Aid received (constant 2012 US$) in Nigeria in 1964 to that in 1967?
Keep it short and to the point. 0.64. What is the ratio of the Aid received (constant 2012 US$) in Turkey in 1964 to that in 1967?
Ensure brevity in your answer.  0.78. What is the ratio of the Aid received (constant 2012 US$) in Libya in 1964 to that in 1968?
Your answer should be compact. 2.96. What is the ratio of the Aid received (constant 2012 US$) of Nigeria in 1964 to that in 1968?
Keep it short and to the point. 0.61. What is the ratio of the Aid received (constant 2012 US$) of Turkey in 1964 to that in 1968?
Your response must be concise. 0.85. What is the ratio of the Aid received (constant 2012 US$) in Libya in 1965 to that in 1966?
Make the answer very short. 3.99. What is the ratio of the Aid received (constant 2012 US$) in Nigeria in 1965 to that in 1966?
Provide a short and direct response. 1.16. What is the ratio of the Aid received (constant 2012 US$) of Turkey in 1965 to that in 1966?
Your answer should be compact. 0.93. What is the ratio of the Aid received (constant 2012 US$) in Libya in 1965 to that in 1967?
Ensure brevity in your answer.  2.67. What is the ratio of the Aid received (constant 2012 US$) of Nigeria in 1965 to that in 1967?
Offer a terse response. 1.13. What is the ratio of the Aid received (constant 2012 US$) in Turkey in 1965 to that in 1967?
Make the answer very short. 0.93. What is the ratio of the Aid received (constant 2012 US$) in Libya in 1965 to that in 1968?
Your answer should be very brief. 1.25. What is the ratio of the Aid received (constant 2012 US$) in Nigeria in 1965 to that in 1968?
Your answer should be very brief. 1.09. What is the ratio of the Aid received (constant 2012 US$) of Turkey in 1965 to that in 1968?
Provide a succinct answer. 1.02. What is the ratio of the Aid received (constant 2012 US$) of Libya in 1966 to that in 1967?
Provide a short and direct response. 0.67. What is the ratio of the Aid received (constant 2012 US$) in Nigeria in 1966 to that in 1967?
Keep it short and to the point. 0.98. What is the ratio of the Aid received (constant 2012 US$) in Libya in 1966 to that in 1968?
Your answer should be very brief. 0.31. What is the ratio of the Aid received (constant 2012 US$) in Nigeria in 1966 to that in 1968?
Provide a short and direct response. 0.94. What is the ratio of the Aid received (constant 2012 US$) in Turkey in 1966 to that in 1968?
Give a very brief answer. 1.1. What is the ratio of the Aid received (constant 2012 US$) in Libya in 1967 to that in 1968?
Make the answer very short. 0.47. What is the ratio of the Aid received (constant 2012 US$) in Nigeria in 1967 to that in 1968?
Give a very brief answer. 0.96. What is the ratio of the Aid received (constant 2012 US$) of Turkey in 1967 to that in 1968?
Provide a short and direct response. 1.1. What is the difference between the highest and the second highest Aid received (constant 2012 US$) in Libya?
Provide a succinct answer. 4.12e+07. What is the difference between the highest and the second highest Aid received (constant 2012 US$) of Nigeria?
Your response must be concise. 4.52e+07. What is the difference between the highest and the second highest Aid received (constant 2012 US$) in Turkey?
Make the answer very short. 4.31e+07. What is the difference between the highest and the lowest Aid received (constant 2012 US$) of Libya?
Your response must be concise. 2.54e+08. What is the difference between the highest and the lowest Aid received (constant 2012 US$) of Nigeria?
Your answer should be very brief. 4.27e+08. What is the difference between the highest and the lowest Aid received (constant 2012 US$) in Turkey?
Provide a short and direct response. 4.40e+08. 